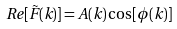Convert formula to latex. <formula><loc_0><loc_0><loc_500><loc_500>R e [ \tilde { F } ( { k } ) ] = A ( { k } ) \cos [ \phi ( { k } ) ]</formula> 